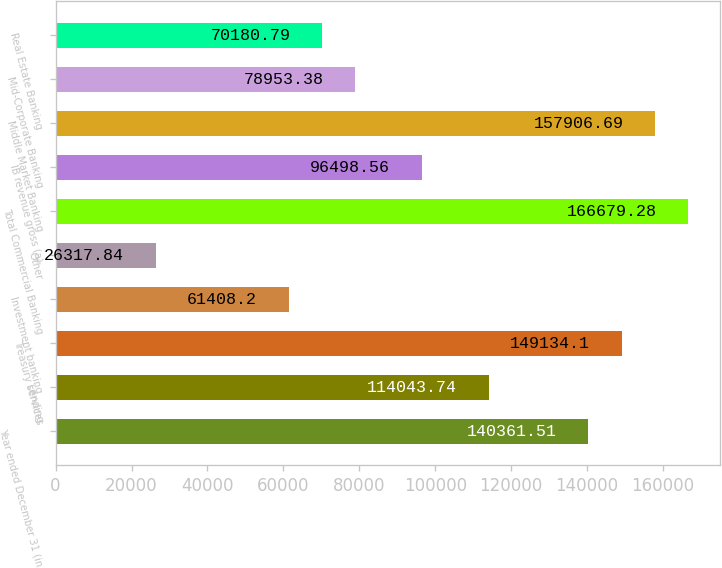Convert chart. <chart><loc_0><loc_0><loc_500><loc_500><bar_chart><fcel>Year ended December 31 (in<fcel>Lending<fcel>Treasury services<fcel>Investment banking<fcel>Other<fcel>Total Commercial Banking<fcel>IB revenue gross (a)<fcel>Middle Market Banking<fcel>Mid-Corporate Banking<fcel>Real Estate Banking<nl><fcel>140362<fcel>114044<fcel>149134<fcel>61408.2<fcel>26317.8<fcel>166679<fcel>96498.6<fcel>157907<fcel>78953.4<fcel>70180.8<nl></chart> 